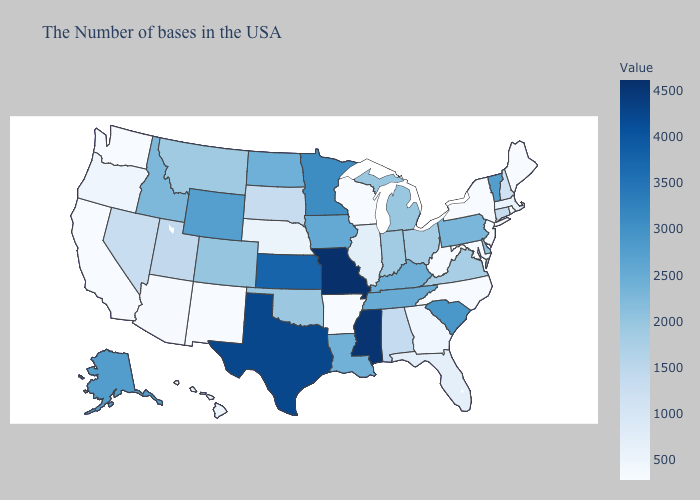Does Missouri have the highest value in the USA?
Quick response, please. Yes. Does Oregon have the highest value in the West?
Give a very brief answer. No. Does Missouri have the highest value in the USA?
Be succinct. Yes. Is the legend a continuous bar?
Write a very short answer. Yes. Does South Dakota have a higher value than Virginia?
Give a very brief answer. No. 